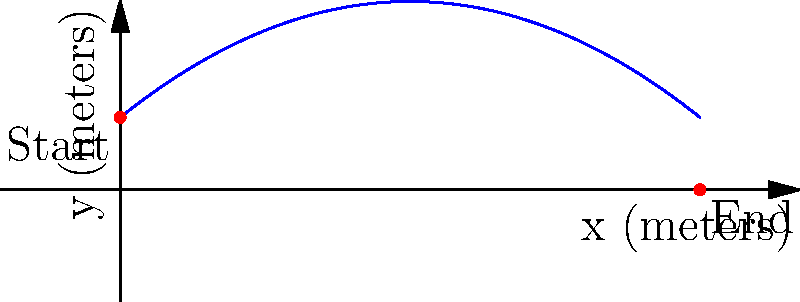As an expert in discus throwing, you're analyzing the trajectory of a throw. The path of the discus can be modeled by the equation $y = -0.05x^2 + 0.8x + 2$, where $x$ and $y$ are measured in meters. The discus is released at a height of 2 meters and lands 16 meters away. What is the maximum height reached by the discus during its flight? To find the maximum height of the discus, we need to follow these steps:

1) The equation of the trajectory is $y = -0.05x^2 + 0.8x + 2$

2) To find the maximum height, we need to find the vertex of this parabola. For a quadratic equation in the form $y = ax^2 + bx + c$, the x-coordinate of the vertex is given by $x = -\frac{b}{2a}$

3) In our equation, $a = -0.05$ and $b = 0.8$

4) Substituting these values:
   $x = -\frac{0.8}{2(-0.05)} = -\frac{0.8}{-0.1} = 8$ meters

5) To find the y-coordinate (height) at this point, we substitute $x = 8$ into our original equation:

   $y = -0.05(8)^2 + 0.8(8) + 2$
   $= -0.05(64) + 6.4 + 2$
   $= -3.2 + 6.4 + 2$
   $= 5.2$ meters

Therefore, the maximum height reached by the discus is 5.2 meters.
Answer: 5.2 meters 